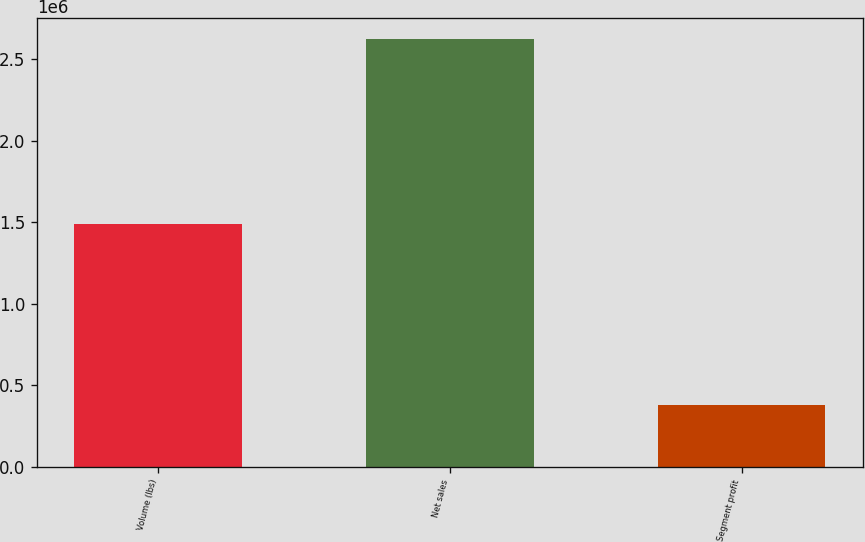Convert chart to OTSL. <chart><loc_0><loc_0><loc_500><loc_500><bar_chart><fcel>Volume (lbs)<fcel>Net sales<fcel>Segment profit<nl><fcel>1.48947e+06<fcel>2.62389e+06<fcel>379378<nl></chart> 